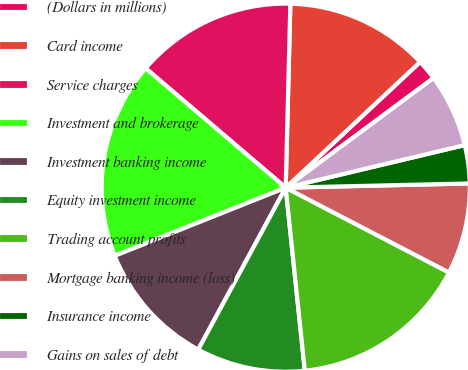Convert chart. <chart><loc_0><loc_0><loc_500><loc_500><pie_chart><fcel>(Dollars in millions)<fcel>Card income<fcel>Service charges<fcel>Investment and brokerage<fcel>Investment banking income<fcel>Equity investment income<fcel>Trading account profits<fcel>Mortgage banking income (loss)<fcel>Insurance income<fcel>Gains on sales of debt<nl><fcel>1.81%<fcel>12.63%<fcel>14.17%<fcel>17.27%<fcel>11.08%<fcel>9.54%<fcel>15.72%<fcel>7.99%<fcel>3.35%<fcel>6.44%<nl></chart> 